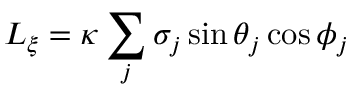<formula> <loc_0><loc_0><loc_500><loc_500>L _ { \xi } = \kappa \sum _ { j } \sigma _ { j } \sin \theta _ { j } \cos \phi _ { j }</formula> 